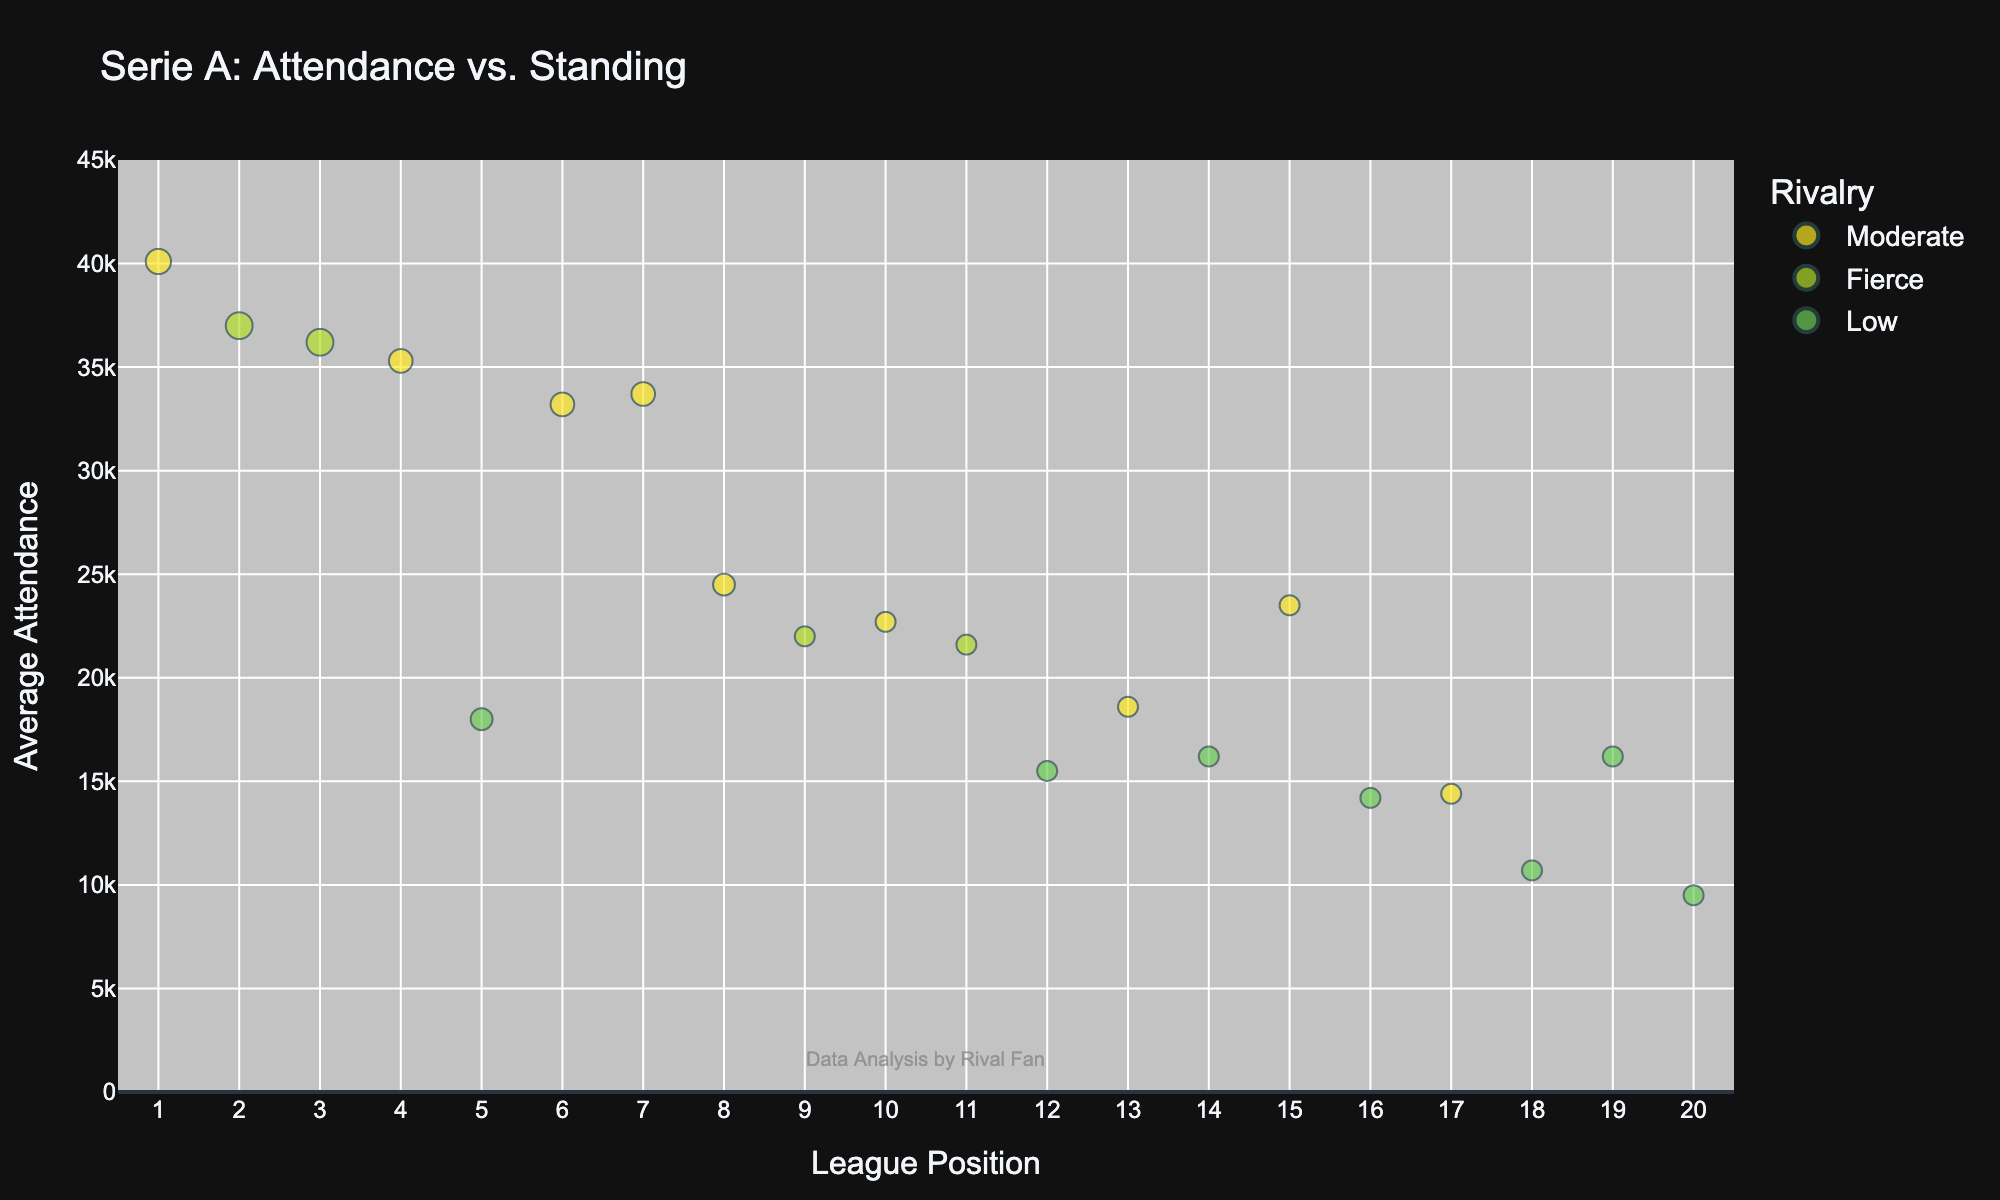What's the title of the figure? The title of the figure is displayed at the top, which provides a summary of what the figure represents. It reads "Serie A: Attendance vs. Standing"
Answer: Serie A: Attendance vs. Standing What does the x-axis represent? The label of the x-axis is provided, which indicates what the axis measures. It is labeled as "League Position"
Answer: League Position How many teams have an average attendance above 35,000? Count the number of data points (bubbles) where the y-value (Attendance) is above 35,000. Juventus, Inter, Milan, and Napoli all have attendance above 35,000.
Answer: Four teams Which team has the second-highest attendance? Compare the y-values (Attendance) of all bubbles to find the second-highest one. The second-highest attendance is for Inter, with 37,000.
Answer: Inter What is the average attendance of the top 3 teams in the standings? To find the average, first determine the attendances of the top 3 teams: Juventus (40,100), Inter (37,000), and Milan (36,200). Sum these values and then divide by 3: (40100 + 37000 + 36200) / 3
Answer: 38,100 Which teams have a fierce rivalry and also an attendance above 21,000? Identify the bubbles where the "Rivalry" attribute is "Fierce" and the y-value (attendance) is more than 21,000. This includes Inter, Milan, Torino, and Genoa.
Answer: Inter, Milan, Torino, Genoa Is there a clear correlation between league position and attendance? Observe if a trend exists where higher league positions (lower numbers) correspond to higher attendances. Generally, there is a trend where higher-ranking teams have higher attendance.
Answer: Yes Between Roma and Lazio, which team has a higher attendance? Locate the bubbles for Roma and Lazio and compare their y-values (Attendances). Roma has an attendance of 33,200 while Lazio has 33,700.
Answer: Lazio What is the difference in attendance between the teams with the highest and lowest significance (magnitude) values? Determine the teams with the highest and lowest magnitude values: Inter (9) and Empoli/Cremonese (2). Compare their attendances: Inter (37,000) and Empoli (10,700), Cremonese (9,500). The differences are 37,000 - 10,700 and 37,000 - 9,500.
Answer: 26,300 & 27,500 Which team’s attendance deviates the most from its standing position? Look for the largest discrepancy between a team's league position and its attendance rank. Atalanta has a high standing (5th) but relatively low attendance (18,000).
Answer: Atalanta 